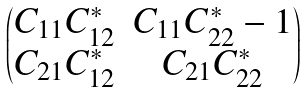Convert formula to latex. <formula><loc_0><loc_0><loc_500><loc_500>\begin{pmatrix} C _ { 1 1 } C _ { 1 2 } ^ { * } & C _ { 1 1 } C _ { 2 2 } ^ { * } - 1 \\ C _ { 2 1 } C _ { 1 2 } ^ { * } & C _ { 2 1 } C _ { 2 2 } ^ { * } \end{pmatrix}</formula> 